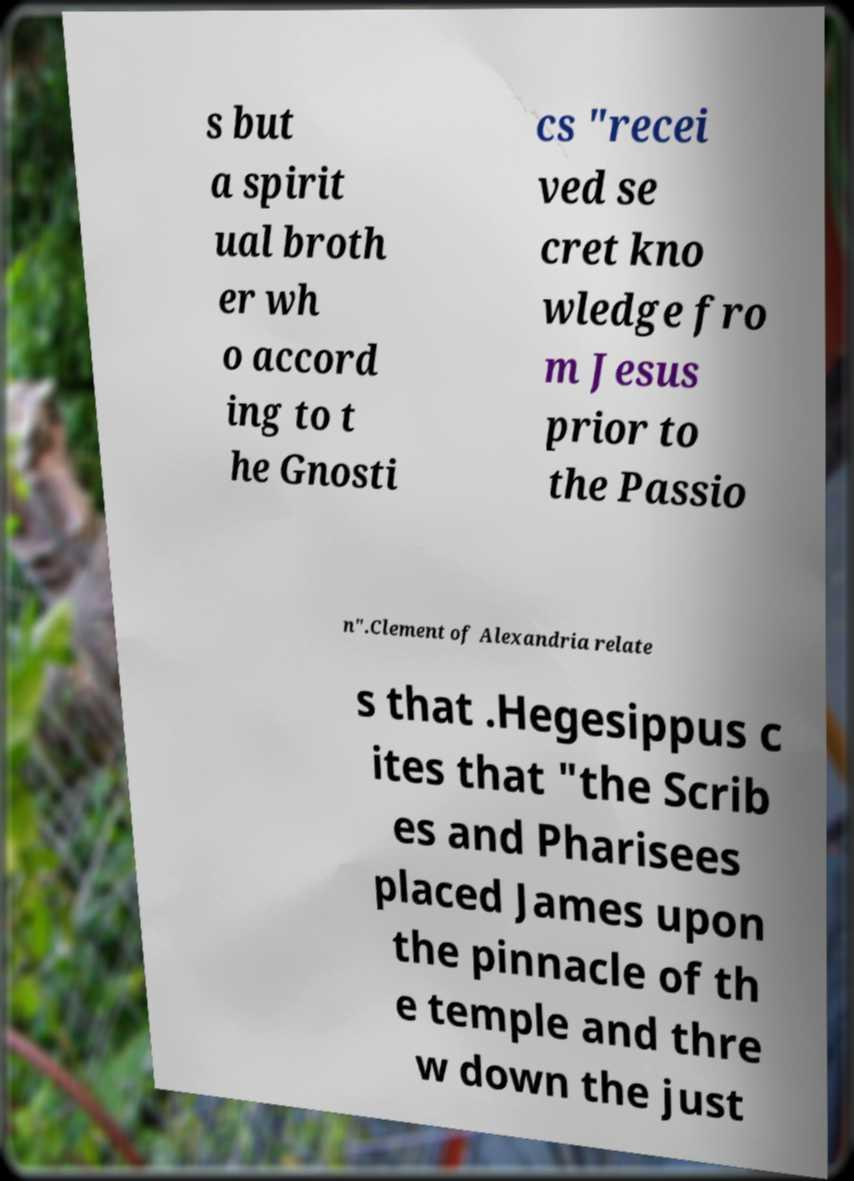Please identify and transcribe the text found in this image. s but a spirit ual broth er wh o accord ing to t he Gnosti cs "recei ved se cret kno wledge fro m Jesus prior to the Passio n".Clement of Alexandria relate s that .Hegesippus c ites that "the Scrib es and Pharisees placed James upon the pinnacle of th e temple and thre w down the just 